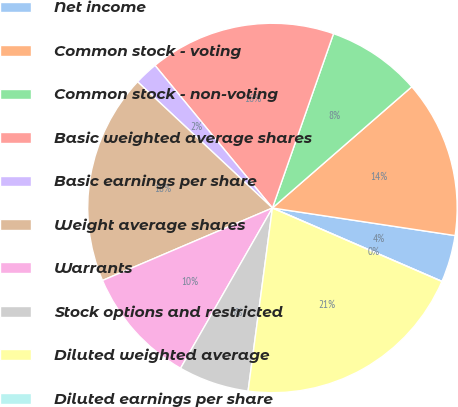Convert chart to OTSL. <chart><loc_0><loc_0><loc_500><loc_500><pie_chart><fcel>Net income<fcel>Common stock - voting<fcel>Common stock - non-voting<fcel>Basic weighted average shares<fcel>Basic earnings per share<fcel>Weight average shares<fcel>Warrants<fcel>Stock options and restricted<fcel>Diluted weighted average<fcel>Diluted earnings per share<nl><fcel>4.12%<fcel>13.78%<fcel>8.24%<fcel>16.33%<fcel>2.06%<fcel>18.39%<fcel>10.3%<fcel>6.18%<fcel>20.6%<fcel>0.0%<nl></chart> 